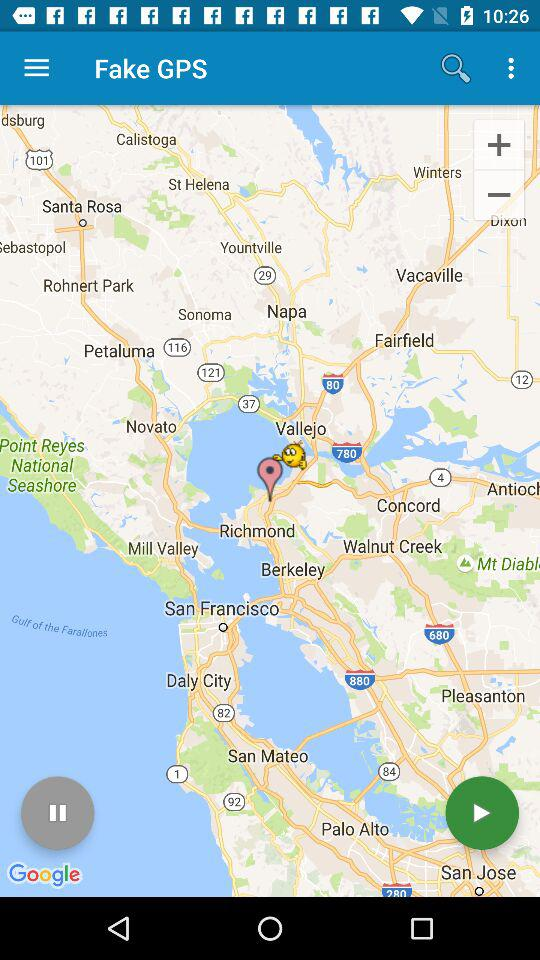What is the name of the application? The name of the application is "Fake GPS". 